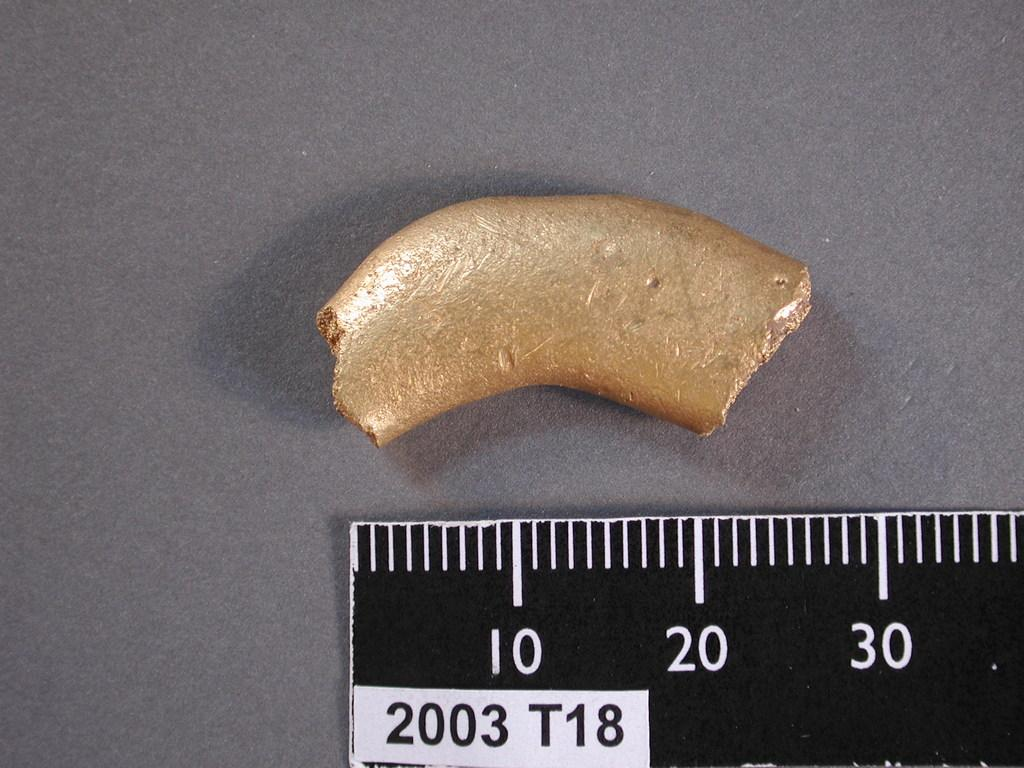<image>
Write a terse but informative summary of the picture. A piece of some metal in from a  ruler that reads 10, 20, and 30. 